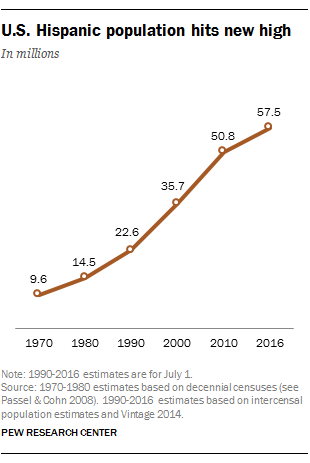Identify some key points in this picture. The sum of the least two populations is greater than the population in 1990. In 2010, the U.S. Hispanic population was approximately 50.8 million. 